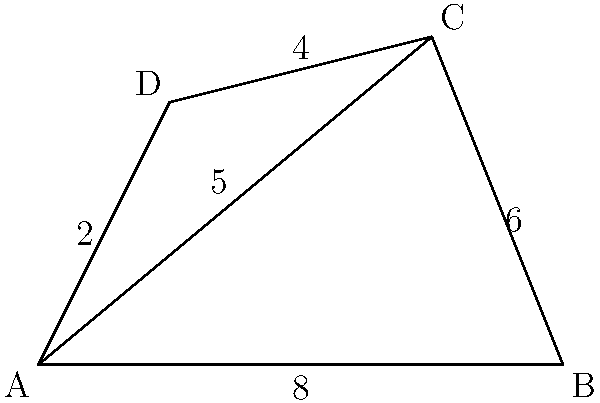A defensive perimeter has an irregular shape as shown in the diagram. Using the triangulation method, calculate the total area of the perimeter. All measurements are in kilometers. To calculate the area of the irregular shape, we can divide it into two triangles: ABC and ACD.

1. Calculate the area of triangle ABC:
   Base = 8 km, Height = 5 km
   Area of ABC = $\frac{1}{2} \times base \times height = \frac{1}{2} \times 8 \times 5 = 20$ sq km

2. Calculate the area of triangle ACD:
   We need to use Heron's formula since we don't have the height.
   Heron's formula: $A = \sqrt{s(s-a)(s-b)(s-c)}$
   where $s = \frac{a+b+c}{2}$ (semi-perimeter)
   $a = 5$ km (AC), $b = 4$ km (CD), $c = 2$ km (AD)

   $s = \frac{5+4+2}{2} = \frac{11}{2} = 5.5$ km

   Area of ACD = $\sqrt{5.5(5.5-5)(5.5-4)(5.5-2)}$
                = $\sqrt{5.5 \times 0.5 \times 1.5 \times 3.5}$
                = $\sqrt{14.4375}$
                ≈ 3.80 sq km

3. Total area = Area of ABC + Area of ACD
              = $20 + 3.80 = 23.80$ sq km
Answer: 23.80 sq km 